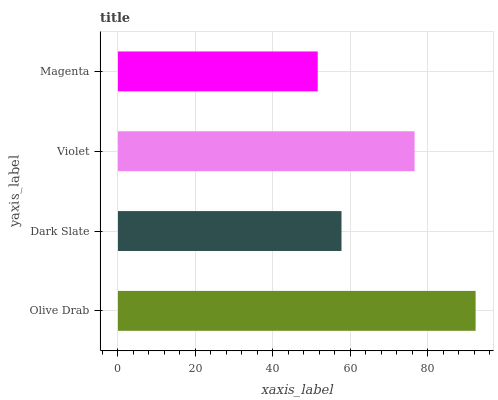Is Magenta the minimum?
Answer yes or no. Yes. Is Olive Drab the maximum?
Answer yes or no. Yes. Is Dark Slate the minimum?
Answer yes or no. No. Is Dark Slate the maximum?
Answer yes or no. No. Is Olive Drab greater than Dark Slate?
Answer yes or no. Yes. Is Dark Slate less than Olive Drab?
Answer yes or no. Yes. Is Dark Slate greater than Olive Drab?
Answer yes or no. No. Is Olive Drab less than Dark Slate?
Answer yes or no. No. Is Violet the high median?
Answer yes or no. Yes. Is Dark Slate the low median?
Answer yes or no. Yes. Is Magenta the high median?
Answer yes or no. No. Is Olive Drab the low median?
Answer yes or no. No. 